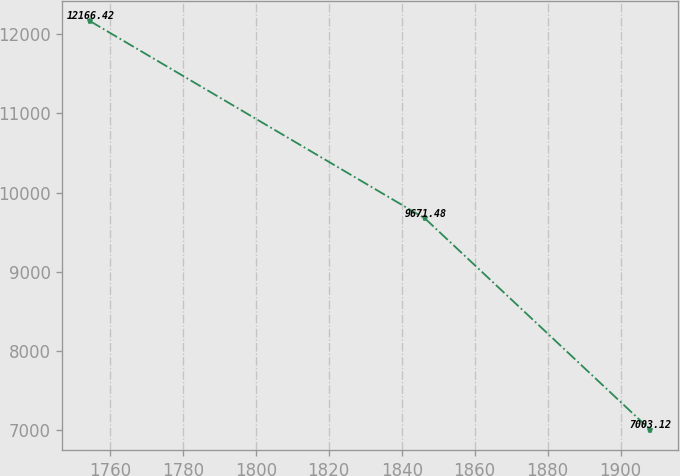Convert chart. <chart><loc_0><loc_0><loc_500><loc_500><line_chart><ecel><fcel>Unnamed: 1<nl><fcel>1754.65<fcel>12166.4<nl><fcel>1846.39<fcel>9671.48<nl><fcel>1908.02<fcel>7003.12<nl></chart> 